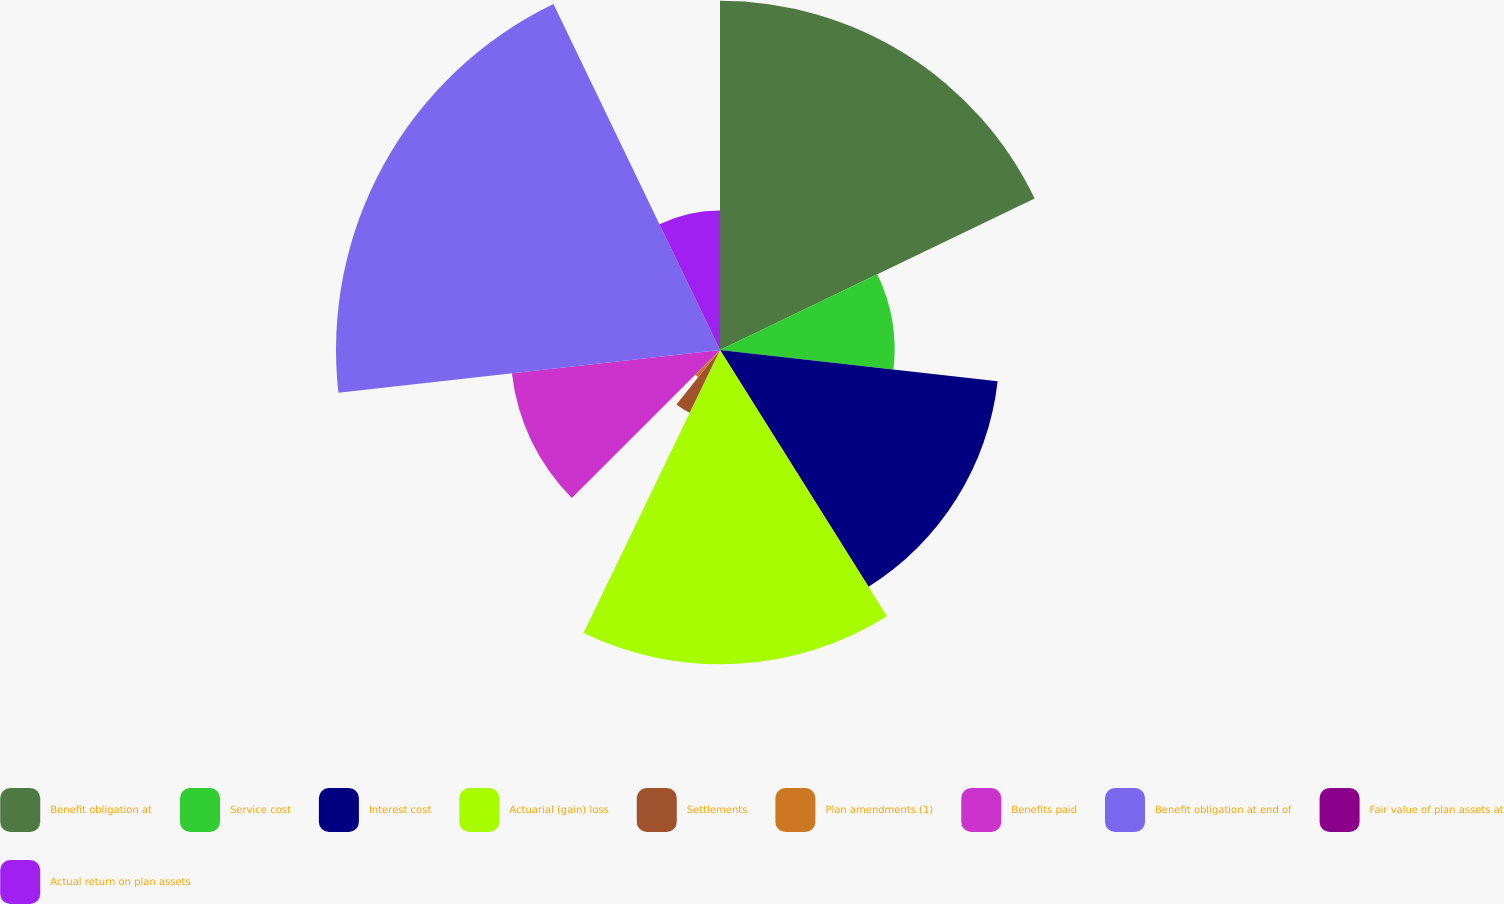Convert chart. <chart><loc_0><loc_0><loc_500><loc_500><pie_chart><fcel>Benefit obligation at<fcel>Service cost<fcel>Interest cost<fcel>Actuarial (gain) loss<fcel>Settlements<fcel>Plan amendments (1)<fcel>Benefits paid<fcel>Benefit obligation at end of<fcel>Fair value of plan assets at<fcel>Actual return on plan assets<nl><fcel>17.86%<fcel>8.93%<fcel>14.29%<fcel>16.07%<fcel>3.57%<fcel>1.79%<fcel>10.71%<fcel>19.64%<fcel>0.0%<fcel>7.14%<nl></chart> 